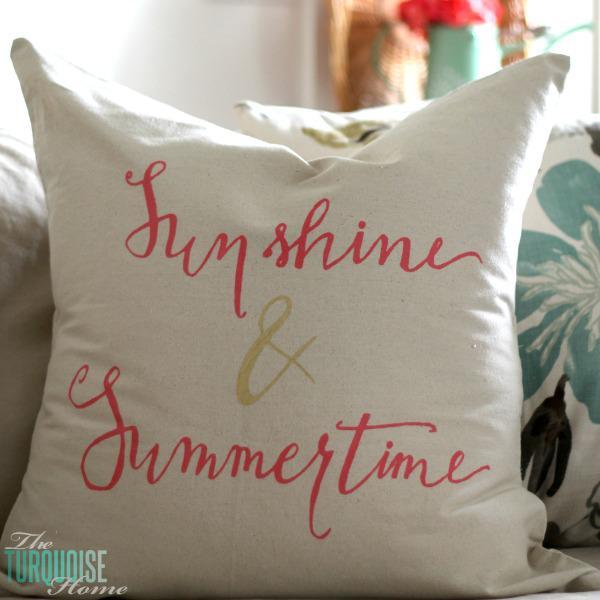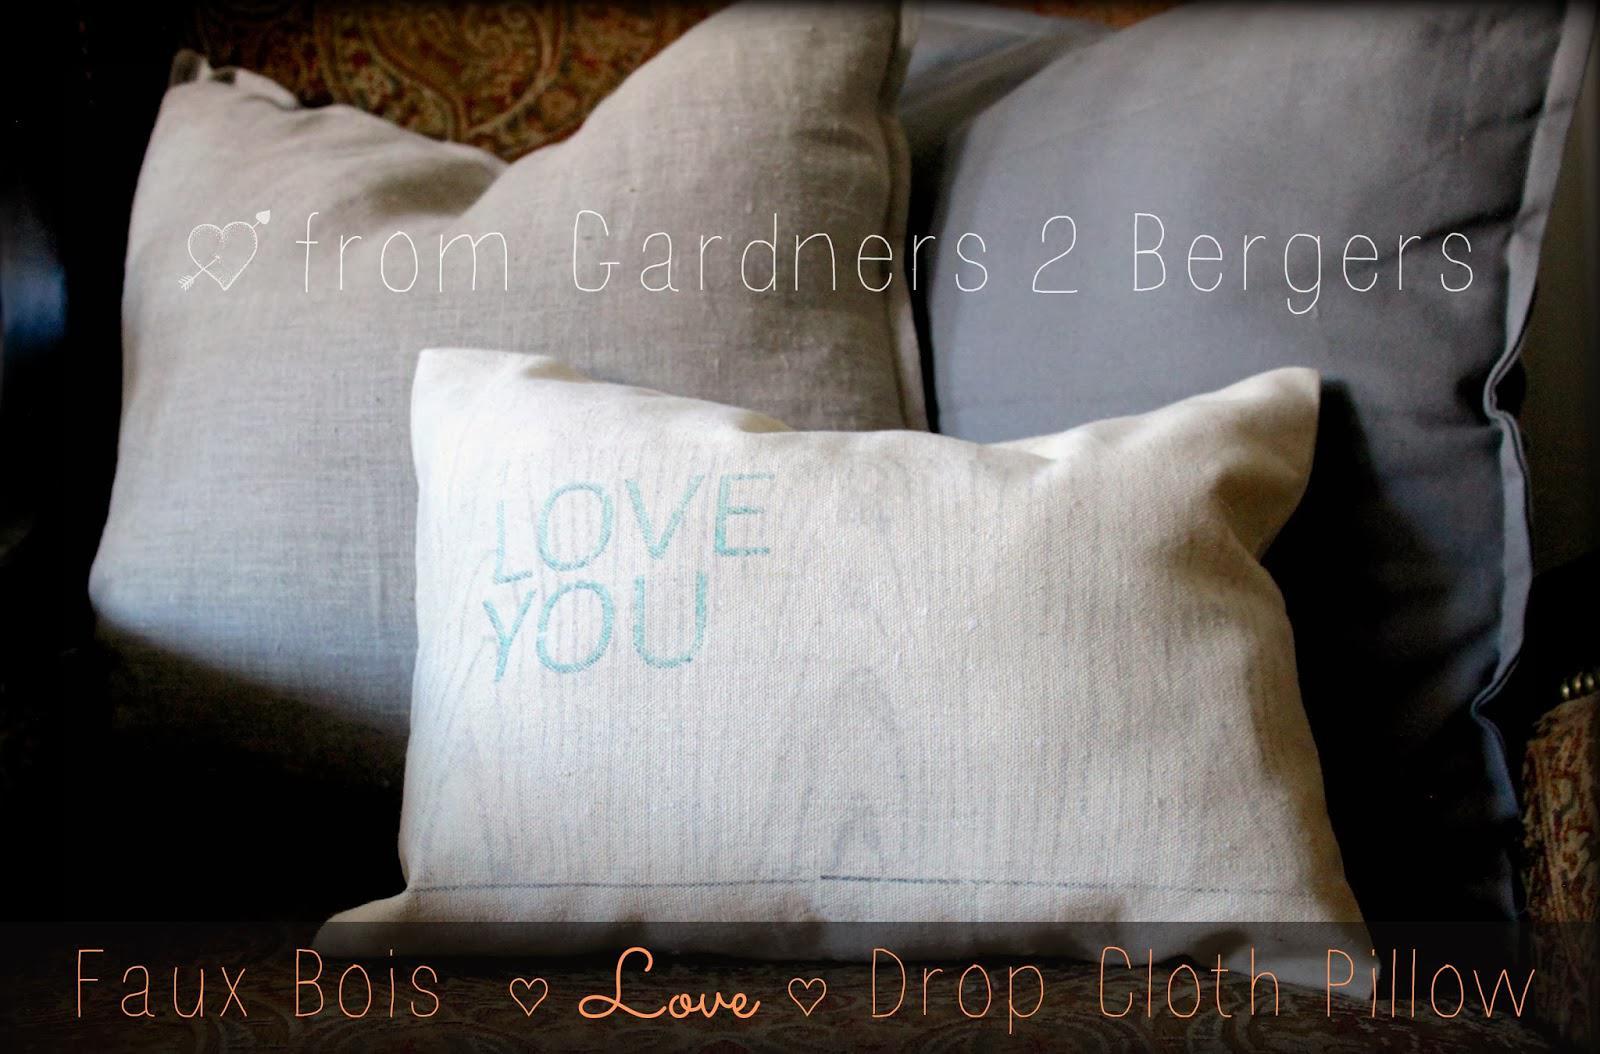The first image is the image on the left, the second image is the image on the right. For the images shown, is this caption "There are two pillow on top of a brown surface." true? Answer yes or no. No. 